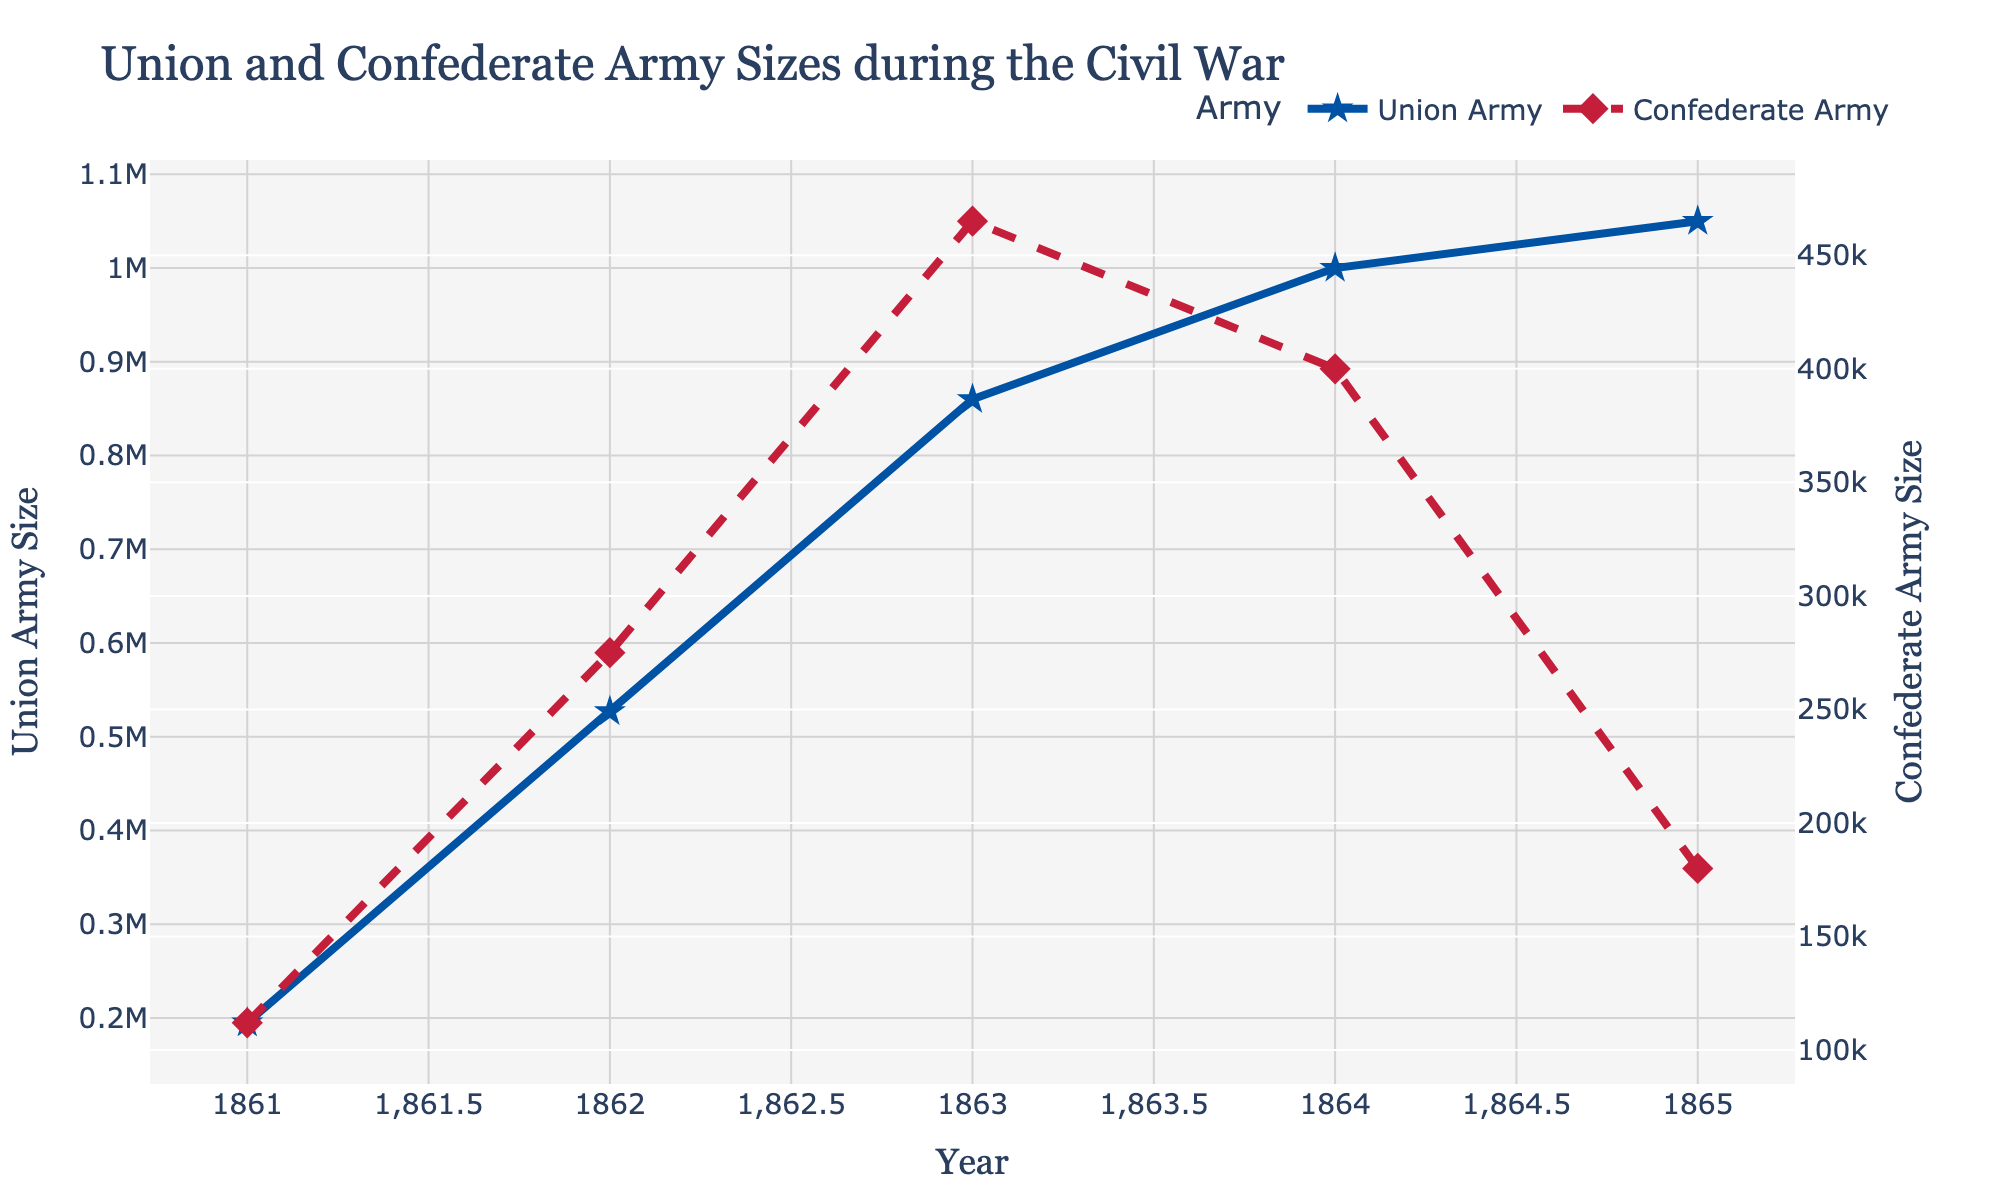What was the Union Army size in 1862? From the chart, we can directly see that the Union Army size in 1862 is represented by the blue line at the year 1862.
Answer: 527000 Which year had the maximum size for the Confederate Army? Looking at the red dashed line, we see the highest point occurs in the year 1863, indicating the maximum size.
Answer: 1863 By what factor did the size of the Union Army increase from 1861 to 1865? In 1861, the Union Army size was 195000, and in 1865 it was 1050000. The factor of increase is calculated by dividing the 1865 size by the 1861 size: 1050000 / 195000 = 5.38.
Answer: 5.38 In which year did the Union Army size first reach 1,000,000? Observing the blue line, we see that the Union Army size first reached 1,000,000 in the year 1864.
Answer: 1864 How did the Confederate Army size change from 1864 to 1865? From the chart, the Confederate Army size dropped from 400000 in 1864 to 180000 in 1865.
Answer: Decreased by 220000 Which army had a greater size in 1863, and by how much? In 1863, the Union Army size was 860000 and the Confederate Army size was 465000. Subtracting these gives 860000 - 465000 = 395000, so the Union Army was larger by 395000.
Answer: Union by 395000 Calculate the average size of the Union Army over the years shown. The sizes are 195000, 527000, 860000, 1000000, and 1050000. Summing them gives 1000000 + 1000000 + 1000000 + 1050000 + 1000000 = 3637000. Dividing by 5 gives 3637000 / 5 = 727400.
Answer: 727400 What is the percentage increase in the Confederate Army size from 1861 to 1862? Initial size in 1861 was 112000 and in 1862 it was 275000. The increase is 275000 - 112000 = 163000. The percentage increase is (163000 / 112000) * 100 ≈ 145.54%.
Answer: 145.54% In which year did the Confederate Army experience its largest decrease in size, and what was the decrease? Comparing sizes between consecutive years, the largest decrease is from 1864 to 1865, where it dropped from 400000 to 180000. The decrease is 400000 - 180000 = 220000.
Answer: 1864 to 1865, by 220000 